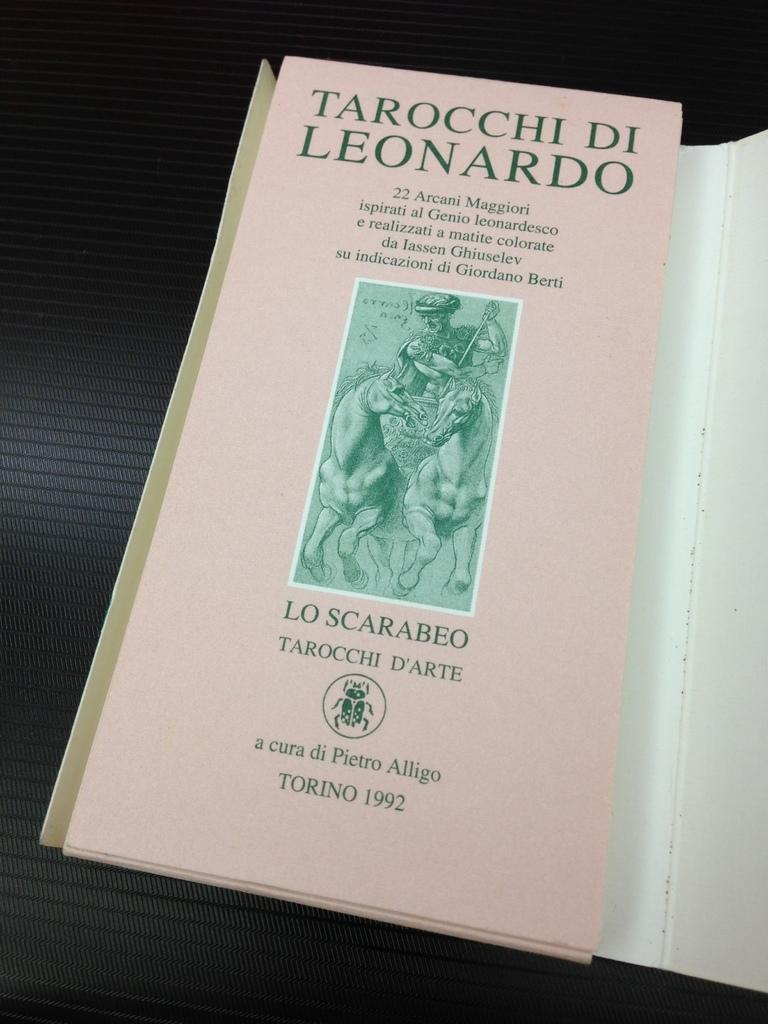<image>
Give a short and clear explanation of the subsequent image. A pink book that isn't in English titled Tarocchi Di Leonardo. 